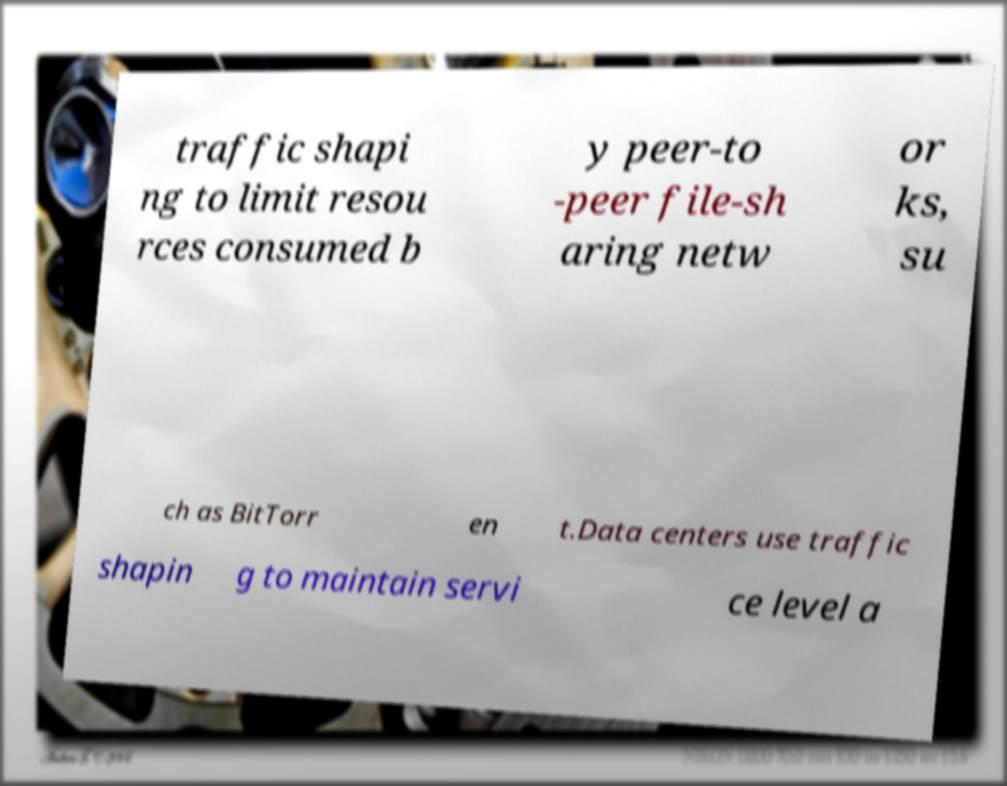Could you extract and type out the text from this image? traffic shapi ng to limit resou rces consumed b y peer-to -peer file-sh aring netw or ks, su ch as BitTorr en t.Data centers use traffic shapin g to maintain servi ce level a 